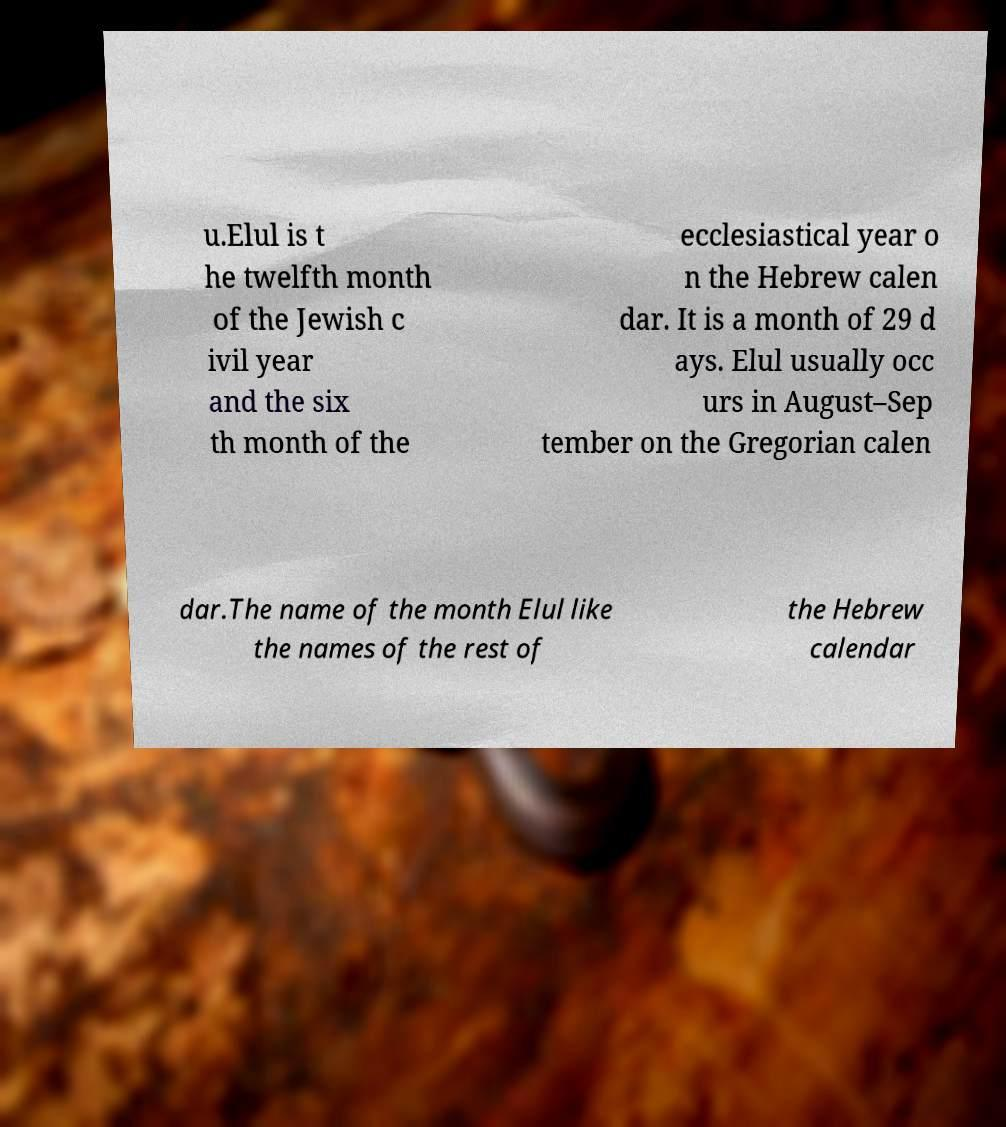I need the written content from this picture converted into text. Can you do that? u.Elul is t he twelfth month of the Jewish c ivil year and the six th month of the ecclesiastical year o n the Hebrew calen dar. It is a month of 29 d ays. Elul usually occ urs in August–Sep tember on the Gregorian calen dar.The name of the month Elul like the names of the rest of the Hebrew calendar 